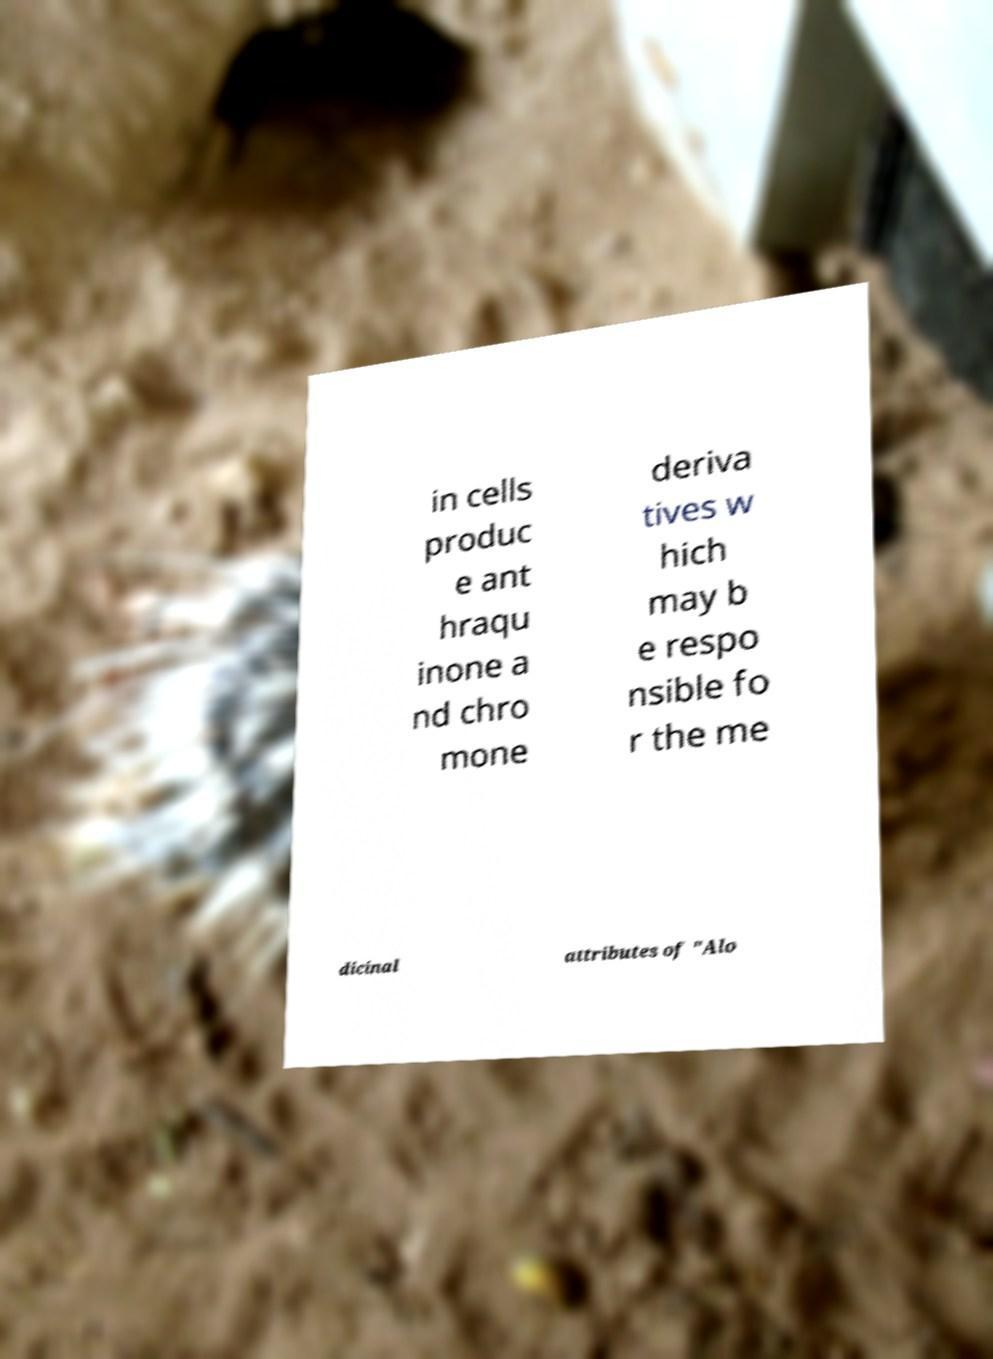Please read and relay the text visible in this image. What does it say? in cells produc e ant hraqu inone a nd chro mone deriva tives w hich may b e respo nsible fo r the me dicinal attributes of "Alo 